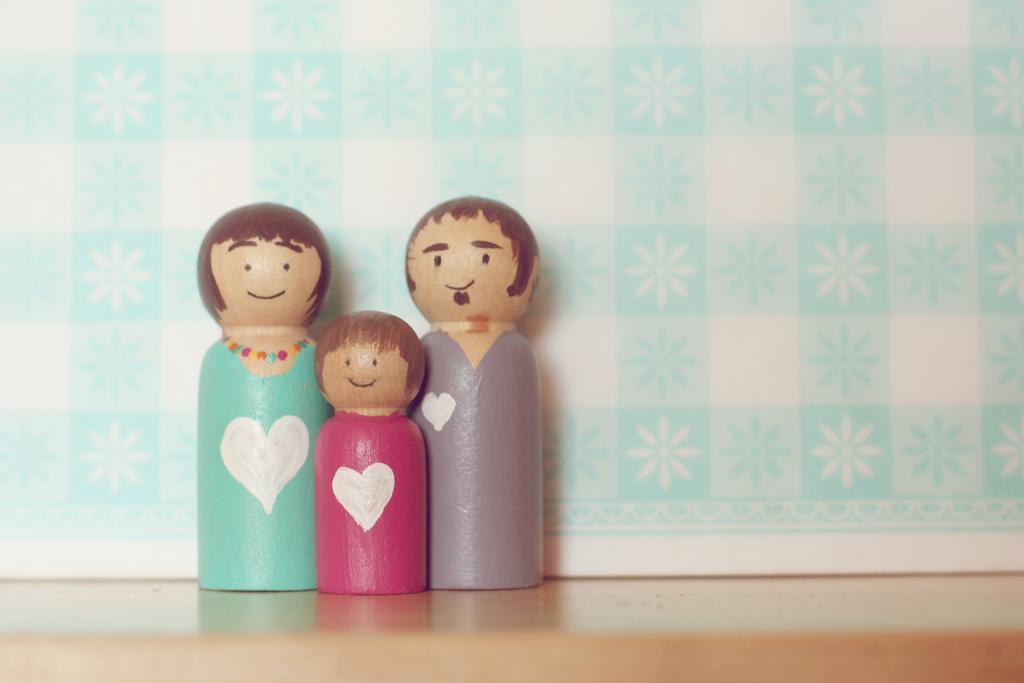Could you give a brief overview of what you see in this image? In this picture, we see three wooden dolls which are in blue, pink and grey color. These dolls might be placed on the brown table. In the background, we see a cloth or a sheet in white and blue color. 